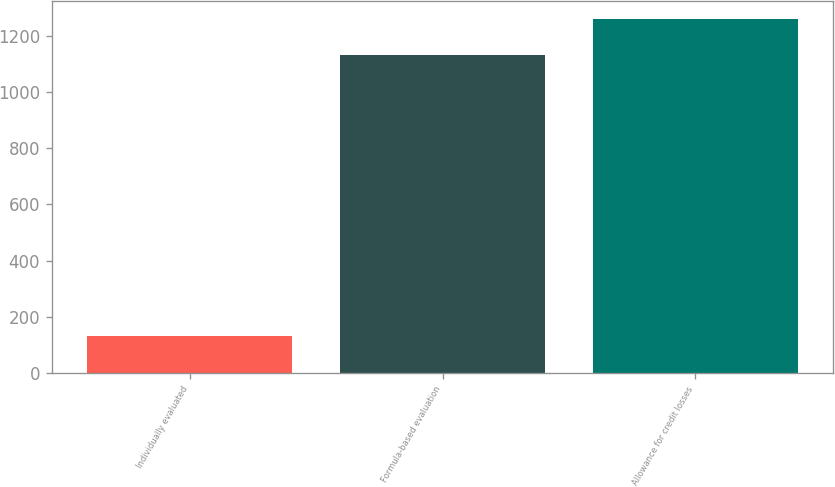Convert chart. <chart><loc_0><loc_0><loc_500><loc_500><bar_chart><fcel>Individually evaluated<fcel>Formula-based evaluation<fcel>Allowance for credit losses<nl><fcel>131<fcel>1129<fcel>1260<nl></chart> 